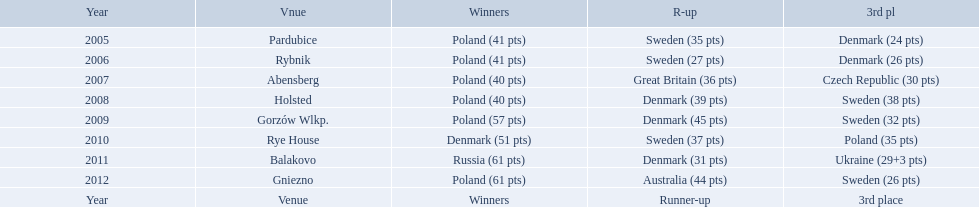In what years did denmark place in the top 3 in the team speedway junior world championship? 2005, 2006, 2008, 2009, 2010, 2011. What in what year did denmark come withing 2 points of placing higher in the standings? 2006. What place did denmark receive the year they missed higher ranking by only 2 points? 3rd place. 